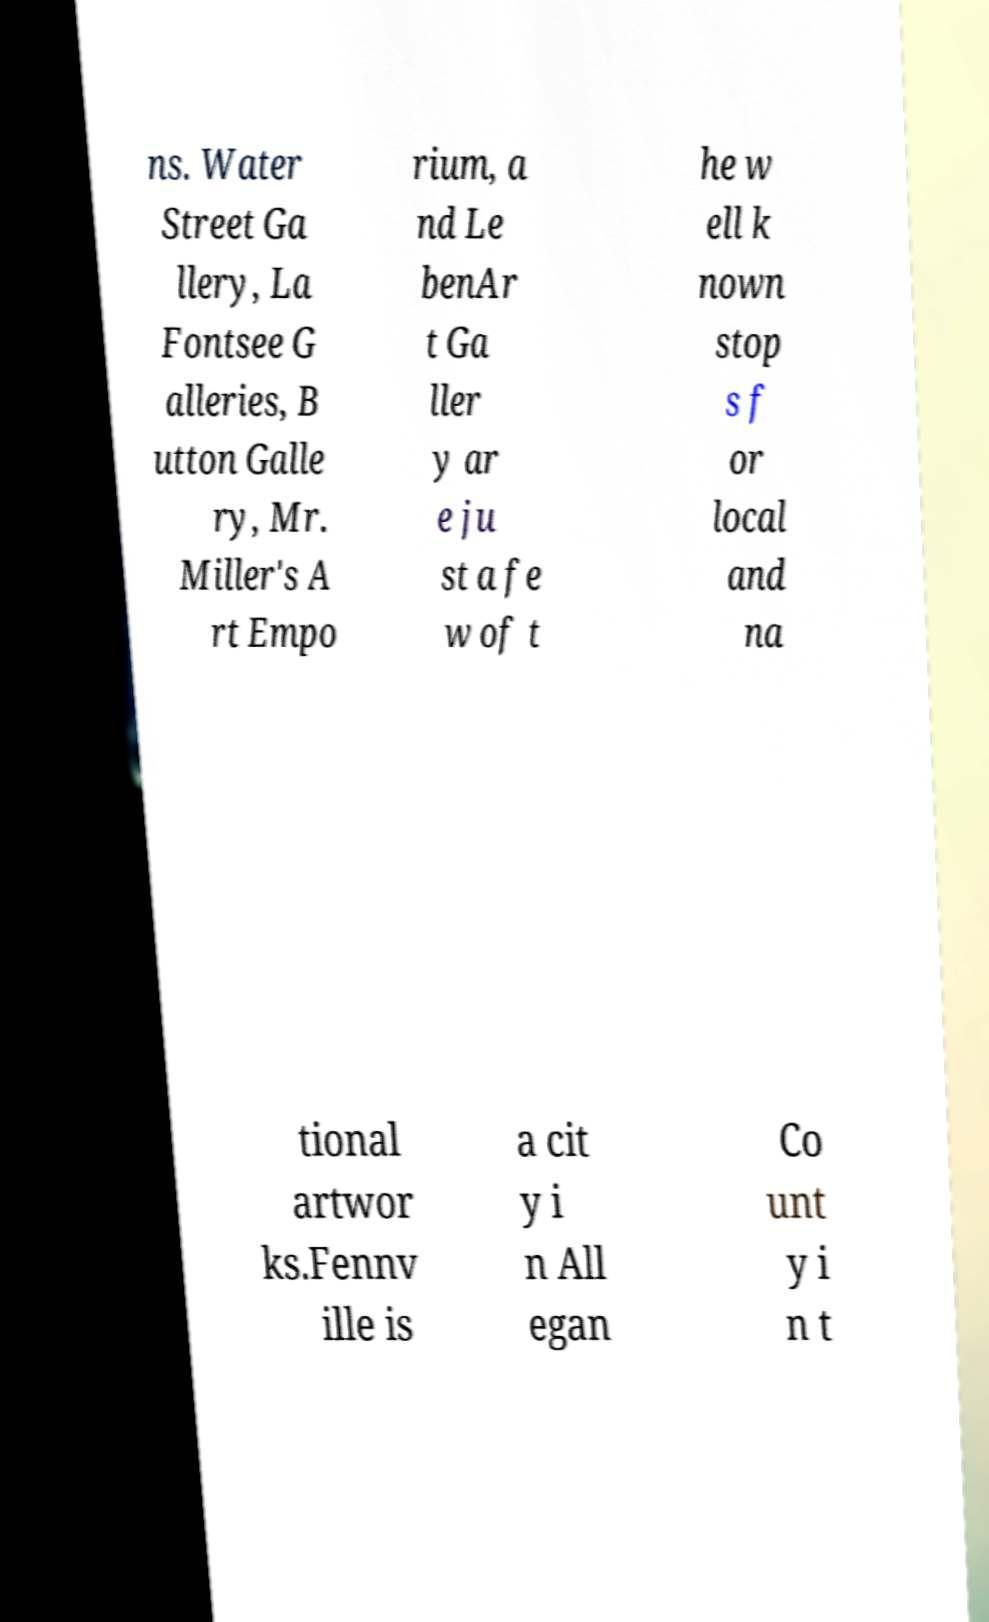Please identify and transcribe the text found in this image. ns. Water Street Ga llery, La Fontsee G alleries, B utton Galle ry, Mr. Miller's A rt Empo rium, a nd Le benAr t Ga ller y ar e ju st a fe w of t he w ell k nown stop s f or local and na tional artwor ks.Fennv ille is a cit y i n All egan Co unt y i n t 